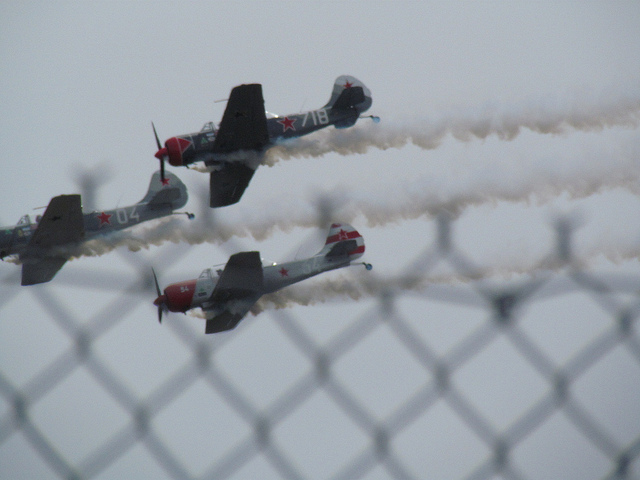How many airplanes are in the photo? 3 